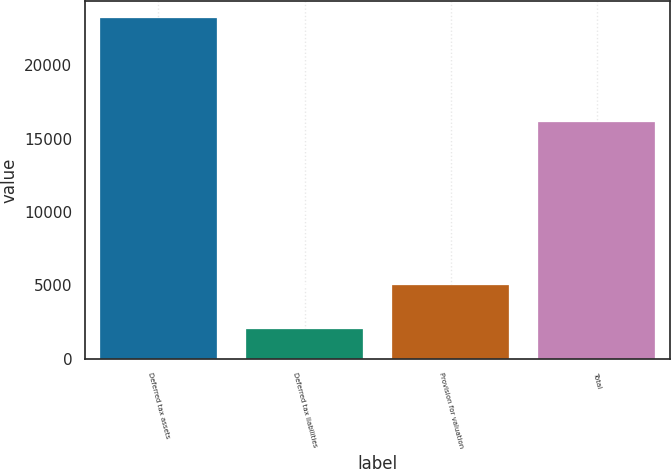Convert chart. <chart><loc_0><loc_0><loc_500><loc_500><bar_chart><fcel>Deferred tax assets<fcel>Deferred tax liabilities<fcel>Provision for valuation<fcel>Total<nl><fcel>23189<fcel>1999<fcel>5041<fcel>16149<nl></chart> 